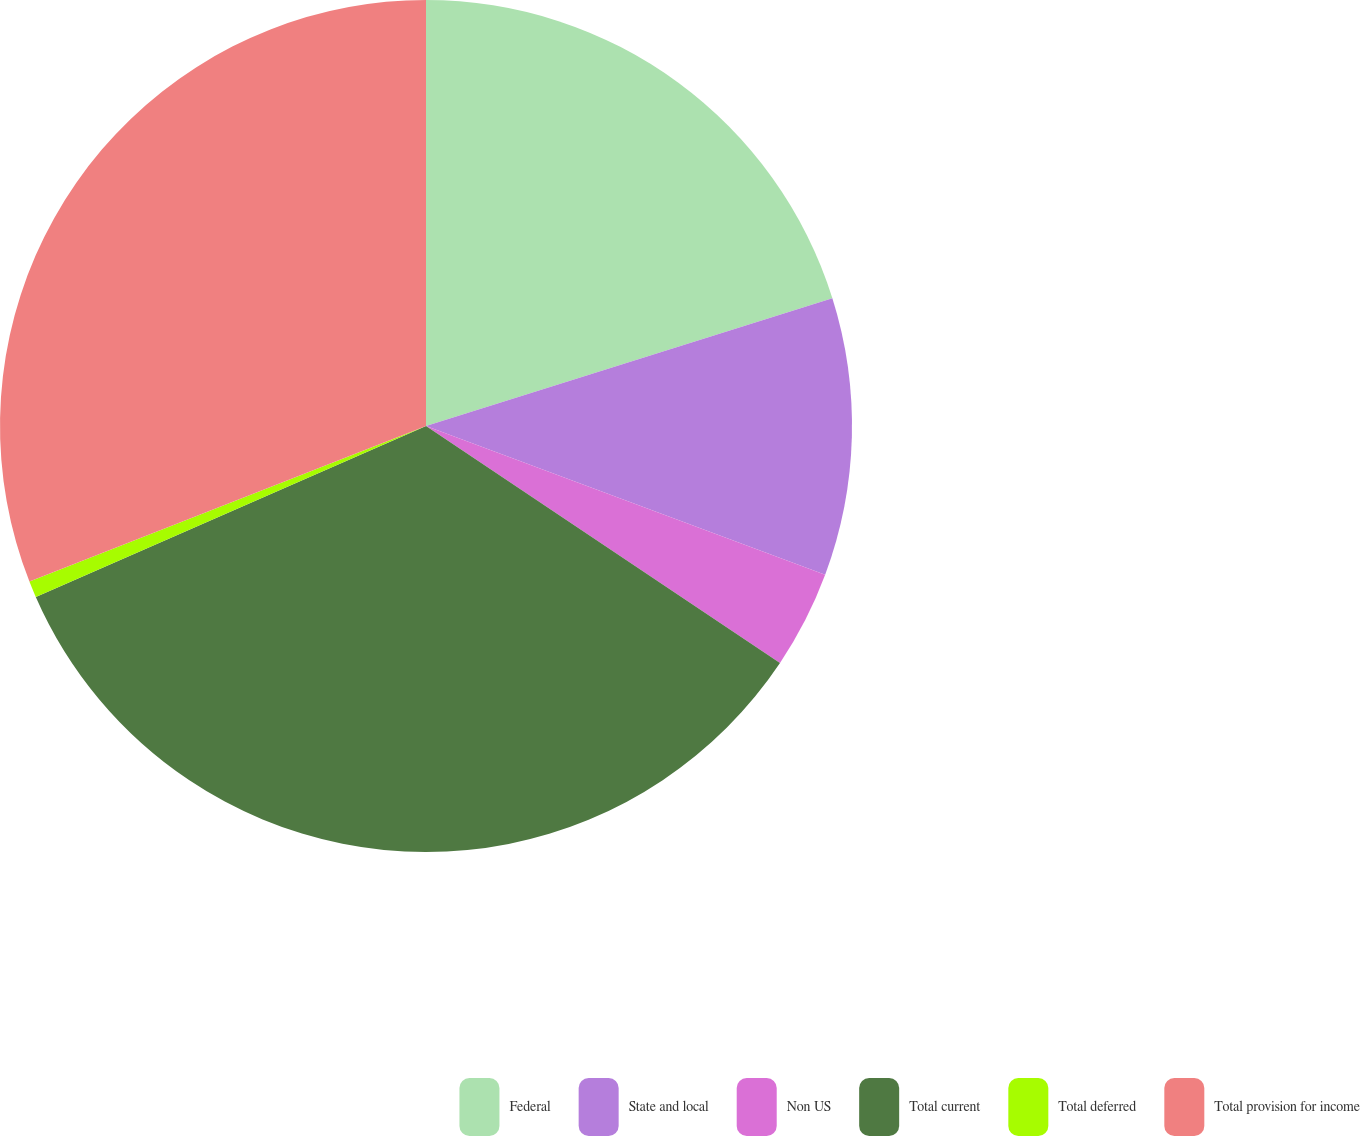Convert chart to OTSL. <chart><loc_0><loc_0><loc_500><loc_500><pie_chart><fcel>Federal<fcel>State and local<fcel>Non US<fcel>Total current<fcel>Total deferred<fcel>Total provision for income<nl><fcel>20.15%<fcel>10.53%<fcel>3.71%<fcel>34.04%<fcel>0.62%<fcel>30.95%<nl></chart> 